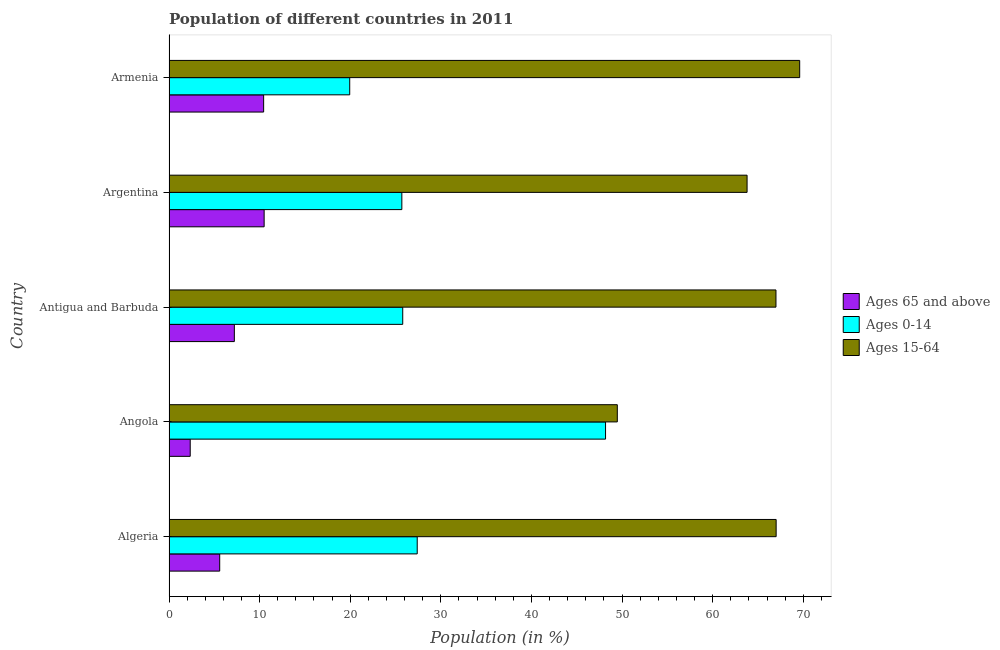How many different coloured bars are there?
Give a very brief answer. 3. Are the number of bars on each tick of the Y-axis equal?
Provide a short and direct response. Yes. What is the label of the 5th group of bars from the top?
Provide a succinct answer. Algeria. In how many cases, is the number of bars for a given country not equal to the number of legend labels?
Your answer should be very brief. 0. What is the percentage of population within the age-group of 65 and above in Antigua and Barbuda?
Your answer should be very brief. 7.21. Across all countries, what is the maximum percentage of population within the age-group 15-64?
Offer a very short reply. 69.61. Across all countries, what is the minimum percentage of population within the age-group 0-14?
Offer a terse response. 19.95. In which country was the percentage of population within the age-group of 65 and above maximum?
Offer a very short reply. Argentina. In which country was the percentage of population within the age-group of 65 and above minimum?
Give a very brief answer. Angola. What is the total percentage of population within the age-group 0-14 in the graph?
Give a very brief answer. 147.02. What is the difference between the percentage of population within the age-group 15-64 in Argentina and that in Armenia?
Ensure brevity in your answer.  -5.81. What is the difference between the percentage of population within the age-group 15-64 in Angola and the percentage of population within the age-group of 65 and above in Antigua and Barbuda?
Offer a terse response. 42.27. What is the average percentage of population within the age-group of 65 and above per country?
Give a very brief answer. 7.22. What is the difference between the percentage of population within the age-group 0-14 and percentage of population within the age-group 15-64 in Antigua and Barbuda?
Provide a succinct answer. -41.19. In how many countries, is the percentage of population within the age-group of 65 and above greater than 62 %?
Your answer should be compact. 0. What is the ratio of the percentage of population within the age-group of 65 and above in Angola to that in Argentina?
Offer a terse response. 0.22. What is the difference between the highest and the second highest percentage of population within the age-group of 65 and above?
Offer a terse response. 0.06. What is the difference between the highest and the lowest percentage of population within the age-group 15-64?
Offer a very short reply. 20.13. In how many countries, is the percentage of population within the age-group 0-14 greater than the average percentage of population within the age-group 0-14 taken over all countries?
Provide a succinct answer. 1. What does the 1st bar from the top in Antigua and Barbuda represents?
Provide a succinct answer. Ages 15-64. What does the 1st bar from the bottom in Armenia represents?
Your answer should be very brief. Ages 65 and above. Is it the case that in every country, the sum of the percentage of population within the age-group of 65 and above and percentage of population within the age-group 0-14 is greater than the percentage of population within the age-group 15-64?
Provide a short and direct response. No. How many bars are there?
Provide a short and direct response. 15. What is the difference between two consecutive major ticks on the X-axis?
Your answer should be very brief. 10. Does the graph contain any zero values?
Make the answer very short. No. Does the graph contain grids?
Ensure brevity in your answer.  No. What is the title of the graph?
Make the answer very short. Population of different countries in 2011. Does "Taxes" appear as one of the legend labels in the graph?
Provide a succinct answer. No. What is the label or title of the X-axis?
Provide a short and direct response. Population (in %). What is the label or title of the Y-axis?
Offer a terse response. Country. What is the Population (in %) of Ages 65 and above in Algeria?
Offer a very short reply. 5.6. What is the Population (in %) of Ages 0-14 in Algeria?
Give a very brief answer. 27.4. What is the Population (in %) in Ages 15-64 in Algeria?
Your answer should be very brief. 67.01. What is the Population (in %) of Ages 65 and above in Angola?
Ensure brevity in your answer.  2.34. What is the Population (in %) of Ages 0-14 in Angola?
Offer a terse response. 48.18. What is the Population (in %) of Ages 15-64 in Angola?
Your response must be concise. 49.48. What is the Population (in %) of Ages 65 and above in Antigua and Barbuda?
Your answer should be compact. 7.21. What is the Population (in %) of Ages 0-14 in Antigua and Barbuda?
Offer a very short reply. 25.8. What is the Population (in %) of Ages 15-64 in Antigua and Barbuda?
Give a very brief answer. 66.99. What is the Population (in %) of Ages 65 and above in Argentina?
Your answer should be very brief. 10.5. What is the Population (in %) in Ages 0-14 in Argentina?
Keep it short and to the point. 25.7. What is the Population (in %) of Ages 15-64 in Argentina?
Give a very brief answer. 63.8. What is the Population (in %) in Ages 65 and above in Armenia?
Your answer should be very brief. 10.45. What is the Population (in %) in Ages 0-14 in Armenia?
Provide a succinct answer. 19.95. What is the Population (in %) in Ages 15-64 in Armenia?
Give a very brief answer. 69.61. Across all countries, what is the maximum Population (in %) in Ages 65 and above?
Keep it short and to the point. 10.5. Across all countries, what is the maximum Population (in %) of Ages 0-14?
Make the answer very short. 48.18. Across all countries, what is the maximum Population (in %) of Ages 15-64?
Provide a succinct answer. 69.61. Across all countries, what is the minimum Population (in %) of Ages 65 and above?
Offer a very short reply. 2.34. Across all countries, what is the minimum Population (in %) in Ages 0-14?
Ensure brevity in your answer.  19.95. Across all countries, what is the minimum Population (in %) in Ages 15-64?
Make the answer very short. 49.48. What is the total Population (in %) in Ages 65 and above in the graph?
Ensure brevity in your answer.  36.1. What is the total Population (in %) of Ages 0-14 in the graph?
Provide a succinct answer. 147.02. What is the total Population (in %) in Ages 15-64 in the graph?
Make the answer very short. 316.89. What is the difference between the Population (in %) in Ages 65 and above in Algeria and that in Angola?
Offer a terse response. 3.25. What is the difference between the Population (in %) in Ages 0-14 in Algeria and that in Angola?
Your answer should be compact. -20.79. What is the difference between the Population (in %) in Ages 15-64 in Algeria and that in Angola?
Provide a short and direct response. 17.53. What is the difference between the Population (in %) in Ages 65 and above in Algeria and that in Antigua and Barbuda?
Ensure brevity in your answer.  -1.62. What is the difference between the Population (in %) in Ages 0-14 in Algeria and that in Antigua and Barbuda?
Provide a short and direct response. 1.6. What is the difference between the Population (in %) of Ages 15-64 in Algeria and that in Antigua and Barbuda?
Give a very brief answer. 0.02. What is the difference between the Population (in %) of Ages 65 and above in Algeria and that in Argentina?
Your answer should be very brief. -4.9. What is the difference between the Population (in %) in Ages 0-14 in Algeria and that in Argentina?
Ensure brevity in your answer.  1.7. What is the difference between the Population (in %) in Ages 15-64 in Algeria and that in Argentina?
Ensure brevity in your answer.  3.21. What is the difference between the Population (in %) of Ages 65 and above in Algeria and that in Armenia?
Provide a succinct answer. -4.85. What is the difference between the Population (in %) of Ages 0-14 in Algeria and that in Armenia?
Provide a succinct answer. 7.45. What is the difference between the Population (in %) of Ages 15-64 in Algeria and that in Armenia?
Your answer should be very brief. -2.6. What is the difference between the Population (in %) in Ages 65 and above in Angola and that in Antigua and Barbuda?
Your response must be concise. -4.87. What is the difference between the Population (in %) in Ages 0-14 in Angola and that in Antigua and Barbuda?
Provide a short and direct response. 22.38. What is the difference between the Population (in %) in Ages 15-64 in Angola and that in Antigua and Barbuda?
Give a very brief answer. -17.51. What is the difference between the Population (in %) in Ages 65 and above in Angola and that in Argentina?
Make the answer very short. -8.16. What is the difference between the Population (in %) of Ages 0-14 in Angola and that in Argentina?
Provide a succinct answer. 22.48. What is the difference between the Population (in %) of Ages 15-64 in Angola and that in Argentina?
Provide a succinct answer. -14.32. What is the difference between the Population (in %) of Ages 65 and above in Angola and that in Armenia?
Offer a very short reply. -8.1. What is the difference between the Population (in %) in Ages 0-14 in Angola and that in Armenia?
Your answer should be very brief. 28.23. What is the difference between the Population (in %) of Ages 15-64 in Angola and that in Armenia?
Keep it short and to the point. -20.13. What is the difference between the Population (in %) in Ages 65 and above in Antigua and Barbuda and that in Argentina?
Give a very brief answer. -3.29. What is the difference between the Population (in %) in Ages 0-14 in Antigua and Barbuda and that in Argentina?
Give a very brief answer. 0.1. What is the difference between the Population (in %) in Ages 15-64 in Antigua and Barbuda and that in Argentina?
Your answer should be very brief. 3.19. What is the difference between the Population (in %) of Ages 65 and above in Antigua and Barbuda and that in Armenia?
Give a very brief answer. -3.23. What is the difference between the Population (in %) in Ages 0-14 in Antigua and Barbuda and that in Armenia?
Make the answer very short. 5.85. What is the difference between the Population (in %) of Ages 15-64 in Antigua and Barbuda and that in Armenia?
Provide a succinct answer. -2.62. What is the difference between the Population (in %) in Ages 65 and above in Argentina and that in Armenia?
Offer a very short reply. 0.06. What is the difference between the Population (in %) in Ages 0-14 in Argentina and that in Armenia?
Offer a terse response. 5.75. What is the difference between the Population (in %) of Ages 15-64 in Argentina and that in Armenia?
Offer a very short reply. -5.81. What is the difference between the Population (in %) of Ages 65 and above in Algeria and the Population (in %) of Ages 0-14 in Angola?
Offer a terse response. -42.58. What is the difference between the Population (in %) of Ages 65 and above in Algeria and the Population (in %) of Ages 15-64 in Angola?
Your answer should be very brief. -43.88. What is the difference between the Population (in %) in Ages 0-14 in Algeria and the Population (in %) in Ages 15-64 in Angola?
Offer a very short reply. -22.08. What is the difference between the Population (in %) in Ages 65 and above in Algeria and the Population (in %) in Ages 0-14 in Antigua and Barbuda?
Offer a very short reply. -20.2. What is the difference between the Population (in %) in Ages 65 and above in Algeria and the Population (in %) in Ages 15-64 in Antigua and Barbuda?
Provide a succinct answer. -61.39. What is the difference between the Population (in %) of Ages 0-14 in Algeria and the Population (in %) of Ages 15-64 in Antigua and Barbuda?
Your answer should be very brief. -39.59. What is the difference between the Population (in %) in Ages 65 and above in Algeria and the Population (in %) in Ages 0-14 in Argentina?
Give a very brief answer. -20.1. What is the difference between the Population (in %) in Ages 65 and above in Algeria and the Population (in %) in Ages 15-64 in Argentina?
Offer a terse response. -58.21. What is the difference between the Population (in %) in Ages 0-14 in Algeria and the Population (in %) in Ages 15-64 in Argentina?
Offer a terse response. -36.41. What is the difference between the Population (in %) of Ages 65 and above in Algeria and the Population (in %) of Ages 0-14 in Armenia?
Ensure brevity in your answer.  -14.35. What is the difference between the Population (in %) in Ages 65 and above in Algeria and the Population (in %) in Ages 15-64 in Armenia?
Make the answer very short. -64.01. What is the difference between the Population (in %) in Ages 0-14 in Algeria and the Population (in %) in Ages 15-64 in Armenia?
Make the answer very short. -42.21. What is the difference between the Population (in %) in Ages 65 and above in Angola and the Population (in %) in Ages 0-14 in Antigua and Barbuda?
Offer a terse response. -23.46. What is the difference between the Population (in %) in Ages 65 and above in Angola and the Population (in %) in Ages 15-64 in Antigua and Barbuda?
Provide a short and direct response. -64.65. What is the difference between the Population (in %) of Ages 0-14 in Angola and the Population (in %) of Ages 15-64 in Antigua and Barbuda?
Make the answer very short. -18.81. What is the difference between the Population (in %) of Ages 65 and above in Angola and the Population (in %) of Ages 0-14 in Argentina?
Offer a very short reply. -23.36. What is the difference between the Population (in %) in Ages 65 and above in Angola and the Population (in %) in Ages 15-64 in Argentina?
Ensure brevity in your answer.  -61.46. What is the difference between the Population (in %) of Ages 0-14 in Angola and the Population (in %) of Ages 15-64 in Argentina?
Provide a short and direct response. -15.62. What is the difference between the Population (in %) of Ages 65 and above in Angola and the Population (in %) of Ages 0-14 in Armenia?
Make the answer very short. -17.61. What is the difference between the Population (in %) of Ages 65 and above in Angola and the Population (in %) of Ages 15-64 in Armenia?
Ensure brevity in your answer.  -67.27. What is the difference between the Population (in %) of Ages 0-14 in Angola and the Population (in %) of Ages 15-64 in Armenia?
Make the answer very short. -21.43. What is the difference between the Population (in %) in Ages 65 and above in Antigua and Barbuda and the Population (in %) in Ages 0-14 in Argentina?
Make the answer very short. -18.49. What is the difference between the Population (in %) in Ages 65 and above in Antigua and Barbuda and the Population (in %) in Ages 15-64 in Argentina?
Provide a succinct answer. -56.59. What is the difference between the Population (in %) of Ages 0-14 in Antigua and Barbuda and the Population (in %) of Ages 15-64 in Argentina?
Offer a very short reply. -38. What is the difference between the Population (in %) of Ages 65 and above in Antigua and Barbuda and the Population (in %) of Ages 0-14 in Armenia?
Provide a short and direct response. -12.73. What is the difference between the Population (in %) of Ages 65 and above in Antigua and Barbuda and the Population (in %) of Ages 15-64 in Armenia?
Keep it short and to the point. -62.4. What is the difference between the Population (in %) of Ages 0-14 in Antigua and Barbuda and the Population (in %) of Ages 15-64 in Armenia?
Your response must be concise. -43.81. What is the difference between the Population (in %) in Ages 65 and above in Argentina and the Population (in %) in Ages 0-14 in Armenia?
Your response must be concise. -9.45. What is the difference between the Population (in %) in Ages 65 and above in Argentina and the Population (in %) in Ages 15-64 in Armenia?
Provide a short and direct response. -59.11. What is the difference between the Population (in %) of Ages 0-14 in Argentina and the Population (in %) of Ages 15-64 in Armenia?
Your answer should be very brief. -43.91. What is the average Population (in %) of Ages 65 and above per country?
Offer a terse response. 7.22. What is the average Population (in %) of Ages 0-14 per country?
Provide a short and direct response. 29.4. What is the average Population (in %) of Ages 15-64 per country?
Make the answer very short. 63.38. What is the difference between the Population (in %) in Ages 65 and above and Population (in %) in Ages 0-14 in Algeria?
Provide a short and direct response. -21.8. What is the difference between the Population (in %) in Ages 65 and above and Population (in %) in Ages 15-64 in Algeria?
Your answer should be compact. -61.41. What is the difference between the Population (in %) of Ages 0-14 and Population (in %) of Ages 15-64 in Algeria?
Give a very brief answer. -39.61. What is the difference between the Population (in %) of Ages 65 and above and Population (in %) of Ages 0-14 in Angola?
Your response must be concise. -45.84. What is the difference between the Population (in %) in Ages 65 and above and Population (in %) in Ages 15-64 in Angola?
Make the answer very short. -47.14. What is the difference between the Population (in %) of Ages 0-14 and Population (in %) of Ages 15-64 in Angola?
Offer a terse response. -1.3. What is the difference between the Population (in %) in Ages 65 and above and Population (in %) in Ages 0-14 in Antigua and Barbuda?
Your response must be concise. -18.58. What is the difference between the Population (in %) of Ages 65 and above and Population (in %) of Ages 15-64 in Antigua and Barbuda?
Provide a succinct answer. -59.78. What is the difference between the Population (in %) in Ages 0-14 and Population (in %) in Ages 15-64 in Antigua and Barbuda?
Your answer should be compact. -41.19. What is the difference between the Population (in %) in Ages 65 and above and Population (in %) in Ages 0-14 in Argentina?
Offer a terse response. -15.2. What is the difference between the Population (in %) in Ages 65 and above and Population (in %) in Ages 15-64 in Argentina?
Ensure brevity in your answer.  -53.3. What is the difference between the Population (in %) in Ages 0-14 and Population (in %) in Ages 15-64 in Argentina?
Make the answer very short. -38.1. What is the difference between the Population (in %) in Ages 65 and above and Population (in %) in Ages 0-14 in Armenia?
Your answer should be compact. -9.5. What is the difference between the Population (in %) of Ages 65 and above and Population (in %) of Ages 15-64 in Armenia?
Ensure brevity in your answer.  -59.16. What is the difference between the Population (in %) in Ages 0-14 and Population (in %) in Ages 15-64 in Armenia?
Make the answer very short. -49.66. What is the ratio of the Population (in %) of Ages 65 and above in Algeria to that in Angola?
Offer a very short reply. 2.39. What is the ratio of the Population (in %) of Ages 0-14 in Algeria to that in Angola?
Your answer should be very brief. 0.57. What is the ratio of the Population (in %) in Ages 15-64 in Algeria to that in Angola?
Offer a terse response. 1.35. What is the ratio of the Population (in %) in Ages 65 and above in Algeria to that in Antigua and Barbuda?
Provide a succinct answer. 0.78. What is the ratio of the Population (in %) in Ages 0-14 in Algeria to that in Antigua and Barbuda?
Ensure brevity in your answer.  1.06. What is the ratio of the Population (in %) in Ages 65 and above in Algeria to that in Argentina?
Your response must be concise. 0.53. What is the ratio of the Population (in %) of Ages 0-14 in Algeria to that in Argentina?
Your answer should be compact. 1.07. What is the ratio of the Population (in %) of Ages 15-64 in Algeria to that in Argentina?
Provide a short and direct response. 1.05. What is the ratio of the Population (in %) in Ages 65 and above in Algeria to that in Armenia?
Your answer should be very brief. 0.54. What is the ratio of the Population (in %) of Ages 0-14 in Algeria to that in Armenia?
Make the answer very short. 1.37. What is the ratio of the Population (in %) of Ages 15-64 in Algeria to that in Armenia?
Your answer should be compact. 0.96. What is the ratio of the Population (in %) of Ages 65 and above in Angola to that in Antigua and Barbuda?
Your answer should be very brief. 0.32. What is the ratio of the Population (in %) in Ages 0-14 in Angola to that in Antigua and Barbuda?
Your response must be concise. 1.87. What is the ratio of the Population (in %) in Ages 15-64 in Angola to that in Antigua and Barbuda?
Offer a terse response. 0.74. What is the ratio of the Population (in %) in Ages 65 and above in Angola to that in Argentina?
Your answer should be very brief. 0.22. What is the ratio of the Population (in %) in Ages 0-14 in Angola to that in Argentina?
Give a very brief answer. 1.87. What is the ratio of the Population (in %) in Ages 15-64 in Angola to that in Argentina?
Ensure brevity in your answer.  0.78. What is the ratio of the Population (in %) of Ages 65 and above in Angola to that in Armenia?
Your response must be concise. 0.22. What is the ratio of the Population (in %) of Ages 0-14 in Angola to that in Armenia?
Provide a succinct answer. 2.42. What is the ratio of the Population (in %) of Ages 15-64 in Angola to that in Armenia?
Your response must be concise. 0.71. What is the ratio of the Population (in %) of Ages 65 and above in Antigua and Barbuda to that in Argentina?
Offer a terse response. 0.69. What is the ratio of the Population (in %) in Ages 65 and above in Antigua and Barbuda to that in Armenia?
Your answer should be very brief. 0.69. What is the ratio of the Population (in %) in Ages 0-14 in Antigua and Barbuda to that in Armenia?
Give a very brief answer. 1.29. What is the ratio of the Population (in %) of Ages 15-64 in Antigua and Barbuda to that in Armenia?
Offer a very short reply. 0.96. What is the ratio of the Population (in %) of Ages 65 and above in Argentina to that in Armenia?
Provide a short and direct response. 1.01. What is the ratio of the Population (in %) in Ages 0-14 in Argentina to that in Armenia?
Your answer should be compact. 1.29. What is the ratio of the Population (in %) in Ages 15-64 in Argentina to that in Armenia?
Keep it short and to the point. 0.92. What is the difference between the highest and the second highest Population (in %) in Ages 65 and above?
Keep it short and to the point. 0.06. What is the difference between the highest and the second highest Population (in %) of Ages 0-14?
Provide a short and direct response. 20.79. What is the difference between the highest and the second highest Population (in %) of Ages 15-64?
Provide a short and direct response. 2.6. What is the difference between the highest and the lowest Population (in %) of Ages 65 and above?
Offer a very short reply. 8.16. What is the difference between the highest and the lowest Population (in %) of Ages 0-14?
Make the answer very short. 28.23. What is the difference between the highest and the lowest Population (in %) in Ages 15-64?
Keep it short and to the point. 20.13. 